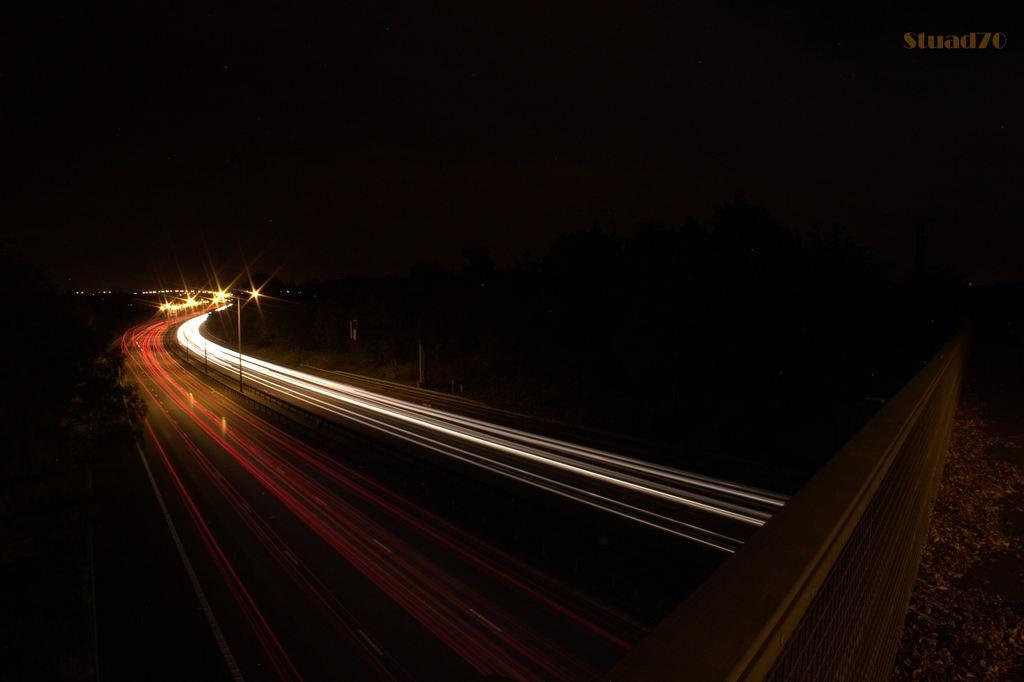What is the overall lighting condition in the image? The image is dark. What type of infrastructure can be seen in the image? There is a road and a bridge in the image. What type of natural elements are present in the image? There are trees in the image. What type of illumination is present on the road? There are lights on the road. What can be seen in the background of the image? The sky is dark in the background of the image. How many ladybugs can be seen crawling on the bridge in the image? There are no ladybugs present in the image; it only features a road, a bridge, trees, lights, and a dark sky. What type of cast is visible on the road in the image? There is no cast present on the road in the image. 